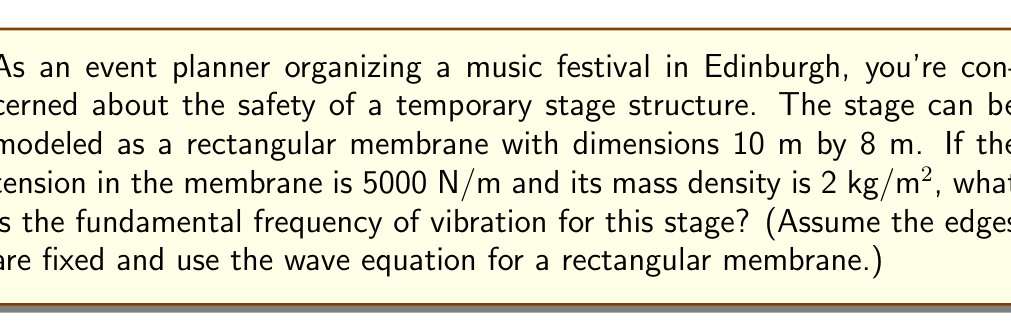Show me your answer to this math problem. Let's approach this step-by-step:

1) The wave equation for a rectangular membrane is given by:

   $$f_{m,n} = \frac{1}{2} \sqrt{\frac{T}{\rho}} \sqrt{\left(\frac{m}{a}\right)^2 + \left(\frac{n}{b}\right)^2}$$

   Where:
   - $f_{m,n}$ is the frequency of vibration
   - $T$ is the tension in the membrane
   - $\rho$ is the mass density
   - $a$ and $b$ are the dimensions of the membrane
   - $m$ and $n$ are mode numbers (positive integers)

2) The fundamental frequency occurs when $m=1$ and $n=1$. So we'll use these values.

3) Let's plug in our known values:
   - $T = 5000$ N/m
   - $\rho = 2$ kg/m²
   - $a = 10$ m
   - $b = 8$ m

4) Now, let's substitute these into our equation:

   $$f_{1,1} = \frac{1}{2} \sqrt{\frac{5000}{2}} \sqrt{\left(\frac{1}{10}\right)^2 + \left(\frac{1}{8}\right)^2}$$

5) Simplify inside the first square root:

   $$f_{1,1} = \frac{1}{2} \sqrt{2500} \sqrt{\frac{1}{100} + \frac{1}{64}}$$

6) Simplify further:

   $$f_{1,1} = \frac{1}{2} \cdot 50 \sqrt{\frac{16+25}{1600}} = 25 \sqrt{\frac{41}{1600}}$$

7) Calculate the final result:

   $$f_{1,1} \approx 4.00 \text{ Hz}$$
Answer: 4.00 Hz 